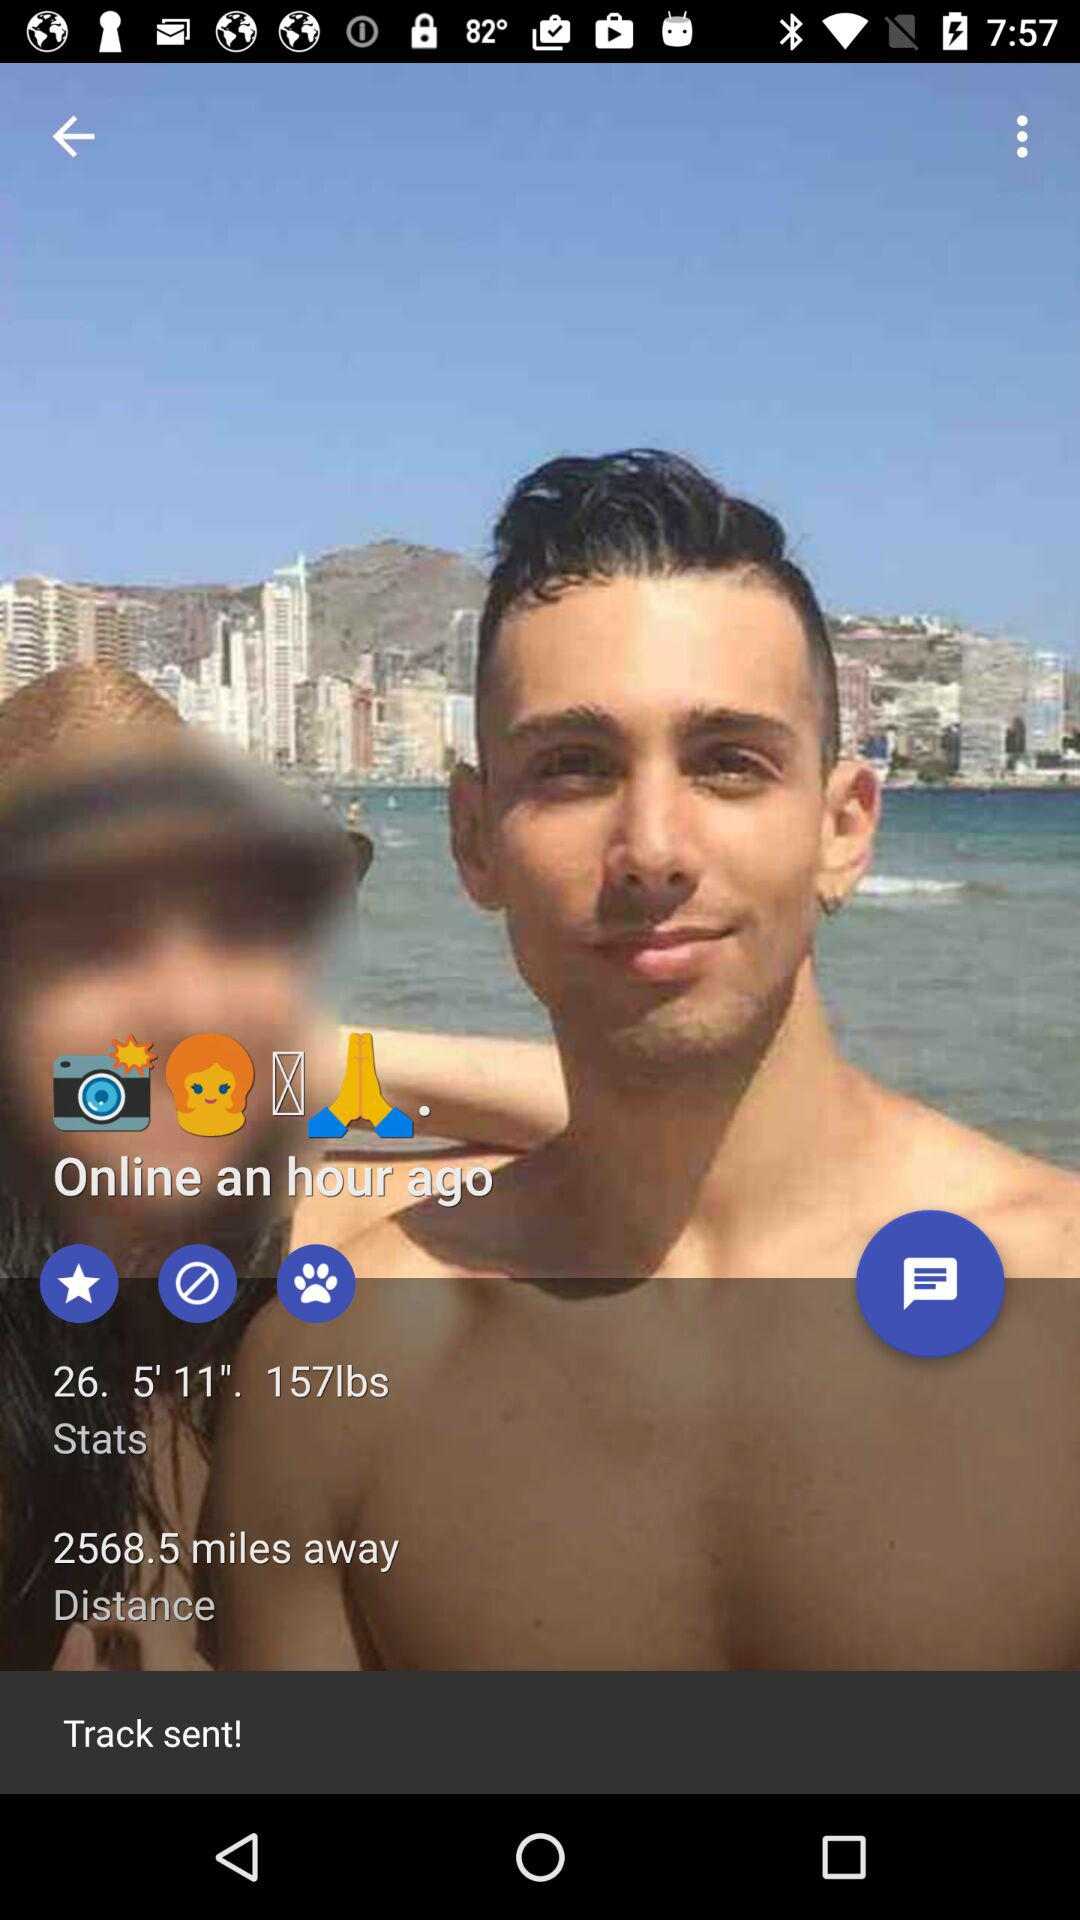How far away is the person? The person is 2568.5 miles away. 